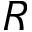Convert formula to latex. <formula><loc_0><loc_0><loc_500><loc_500>R</formula> 